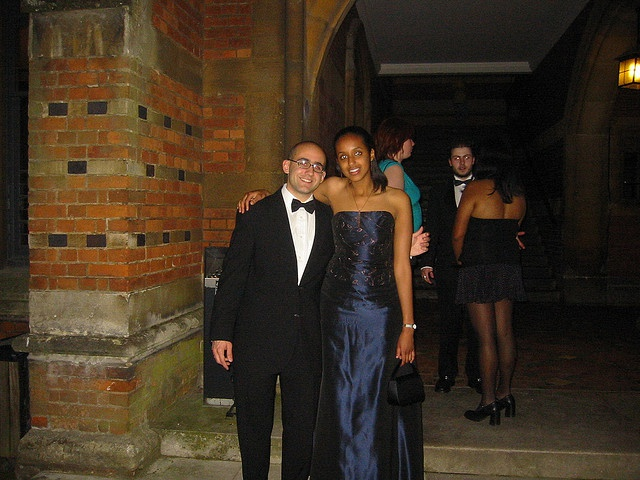Describe the objects in this image and their specific colors. I can see people in black, ivory, gray, and olive tones, people in black, brown, and gray tones, people in black, maroon, and brown tones, people in black, maroon, and brown tones, and people in black, teal, brown, and maroon tones in this image. 